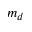Convert formula to latex. <formula><loc_0><loc_0><loc_500><loc_500>m _ { d }</formula> 